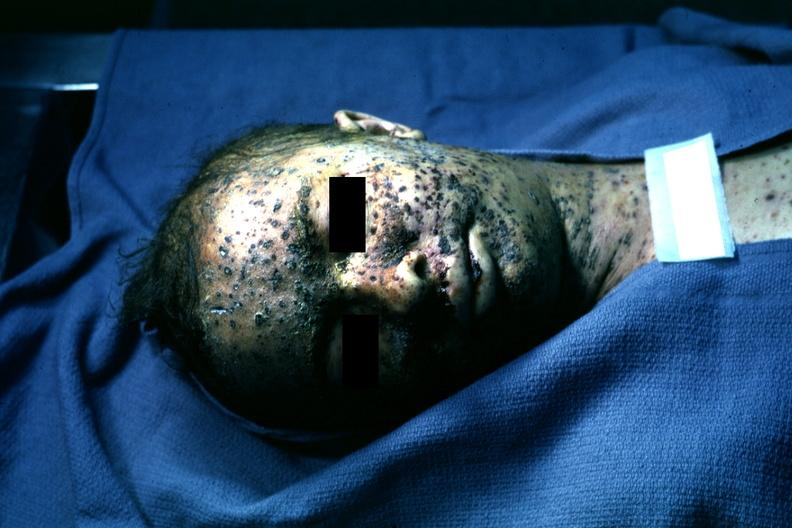what is present?
Answer the question using a single word or phrase. Face 